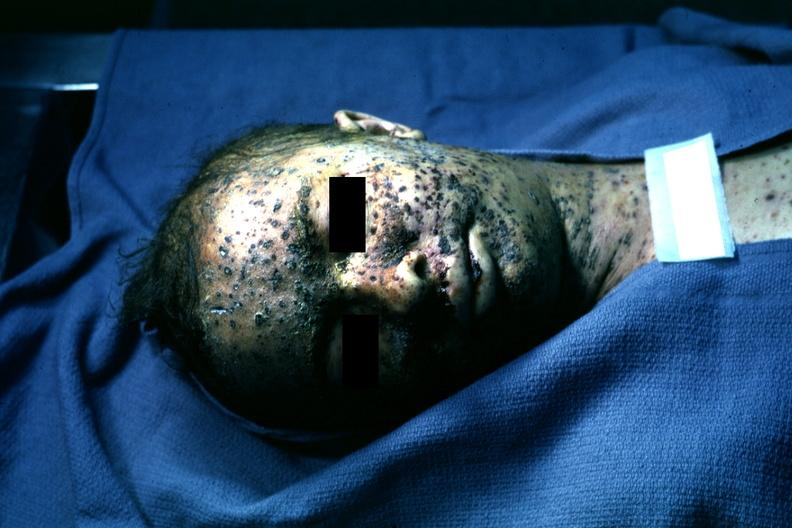what is present?
Answer the question using a single word or phrase. Face 